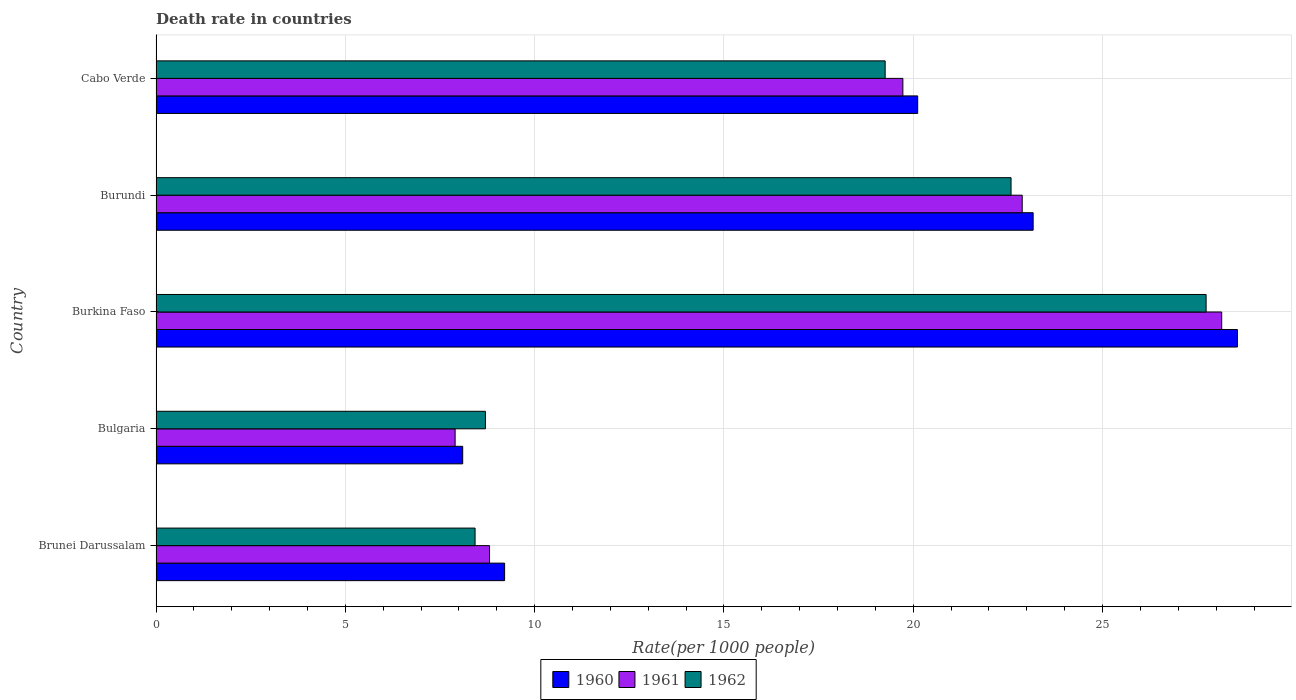Are the number of bars per tick equal to the number of legend labels?
Your answer should be compact. Yes. Are the number of bars on each tick of the Y-axis equal?
Your answer should be compact. Yes. What is the label of the 3rd group of bars from the top?
Keep it short and to the point. Burkina Faso. What is the death rate in 1962 in Burundi?
Offer a very short reply. 22.58. Across all countries, what is the maximum death rate in 1962?
Your response must be concise. 27.73. Across all countries, what is the minimum death rate in 1960?
Your answer should be compact. 8.1. In which country was the death rate in 1961 maximum?
Make the answer very short. Burkina Faso. In which country was the death rate in 1961 minimum?
Offer a terse response. Bulgaria. What is the total death rate in 1960 in the graph?
Give a very brief answer. 89.15. What is the difference between the death rate in 1961 in Bulgaria and that in Burundi?
Ensure brevity in your answer.  -14.98. What is the difference between the death rate in 1962 in Burundi and the death rate in 1961 in Brunei Darussalam?
Your answer should be very brief. 13.77. What is the average death rate in 1962 per country?
Ensure brevity in your answer.  17.34. What is the difference between the death rate in 1960 and death rate in 1961 in Burundi?
Ensure brevity in your answer.  0.29. What is the ratio of the death rate in 1960 in Brunei Darussalam to that in Burkina Faso?
Offer a terse response. 0.32. Is the death rate in 1962 in Brunei Darussalam less than that in Burundi?
Make the answer very short. Yes. What is the difference between the highest and the second highest death rate in 1960?
Your answer should be compact. 5.39. What is the difference between the highest and the lowest death rate in 1961?
Make the answer very short. 20.25. Is it the case that in every country, the sum of the death rate in 1960 and death rate in 1961 is greater than the death rate in 1962?
Your answer should be compact. Yes. How many bars are there?
Offer a very short reply. 15. Are all the bars in the graph horizontal?
Your response must be concise. Yes. What is the difference between two consecutive major ticks on the X-axis?
Give a very brief answer. 5. Does the graph contain any zero values?
Ensure brevity in your answer.  No. How many legend labels are there?
Give a very brief answer. 3. What is the title of the graph?
Offer a very short reply. Death rate in countries. What is the label or title of the X-axis?
Provide a short and direct response. Rate(per 1000 people). What is the label or title of the Y-axis?
Provide a short and direct response. Country. What is the Rate(per 1000 people) in 1960 in Brunei Darussalam?
Your answer should be compact. 9.21. What is the Rate(per 1000 people) in 1961 in Brunei Darussalam?
Ensure brevity in your answer.  8.81. What is the Rate(per 1000 people) in 1962 in Brunei Darussalam?
Provide a succinct answer. 8.43. What is the Rate(per 1000 people) of 1961 in Bulgaria?
Provide a succinct answer. 7.9. What is the Rate(per 1000 people) in 1962 in Bulgaria?
Ensure brevity in your answer.  8.7. What is the Rate(per 1000 people) of 1960 in Burkina Faso?
Offer a very short reply. 28.56. What is the Rate(per 1000 people) of 1961 in Burkina Faso?
Offer a terse response. 28.15. What is the Rate(per 1000 people) of 1962 in Burkina Faso?
Provide a succinct answer. 27.73. What is the Rate(per 1000 people) of 1960 in Burundi?
Offer a very short reply. 23.17. What is the Rate(per 1000 people) in 1961 in Burundi?
Make the answer very short. 22.88. What is the Rate(per 1000 people) of 1962 in Burundi?
Give a very brief answer. 22.58. What is the Rate(per 1000 people) in 1960 in Cabo Verde?
Provide a succinct answer. 20.12. What is the Rate(per 1000 people) of 1961 in Cabo Verde?
Provide a short and direct response. 19.73. What is the Rate(per 1000 people) in 1962 in Cabo Verde?
Your answer should be very brief. 19.26. Across all countries, what is the maximum Rate(per 1000 people) of 1960?
Ensure brevity in your answer.  28.56. Across all countries, what is the maximum Rate(per 1000 people) of 1961?
Ensure brevity in your answer.  28.15. Across all countries, what is the maximum Rate(per 1000 people) in 1962?
Keep it short and to the point. 27.73. Across all countries, what is the minimum Rate(per 1000 people) in 1960?
Offer a very short reply. 8.1. Across all countries, what is the minimum Rate(per 1000 people) of 1962?
Give a very brief answer. 8.43. What is the total Rate(per 1000 people) of 1960 in the graph?
Provide a short and direct response. 89.15. What is the total Rate(per 1000 people) of 1961 in the graph?
Your response must be concise. 87.46. What is the total Rate(per 1000 people) in 1962 in the graph?
Ensure brevity in your answer.  86.7. What is the difference between the Rate(per 1000 people) in 1960 in Brunei Darussalam and that in Bulgaria?
Your answer should be very brief. 1.11. What is the difference between the Rate(per 1000 people) in 1961 in Brunei Darussalam and that in Bulgaria?
Give a very brief answer. 0.91. What is the difference between the Rate(per 1000 people) of 1962 in Brunei Darussalam and that in Bulgaria?
Your answer should be compact. -0.27. What is the difference between the Rate(per 1000 people) of 1960 in Brunei Darussalam and that in Burkina Faso?
Ensure brevity in your answer.  -19.36. What is the difference between the Rate(per 1000 people) in 1961 in Brunei Darussalam and that in Burkina Faso?
Make the answer very short. -19.34. What is the difference between the Rate(per 1000 people) in 1962 in Brunei Darussalam and that in Burkina Faso?
Offer a very short reply. -19.31. What is the difference between the Rate(per 1000 people) of 1960 in Brunei Darussalam and that in Burundi?
Offer a very short reply. -13.96. What is the difference between the Rate(per 1000 people) of 1961 in Brunei Darussalam and that in Burundi?
Offer a very short reply. -14.07. What is the difference between the Rate(per 1000 people) in 1962 in Brunei Darussalam and that in Burundi?
Keep it short and to the point. -14.16. What is the difference between the Rate(per 1000 people) of 1960 in Brunei Darussalam and that in Cabo Verde?
Offer a very short reply. -10.91. What is the difference between the Rate(per 1000 people) of 1961 in Brunei Darussalam and that in Cabo Verde?
Your answer should be very brief. -10.92. What is the difference between the Rate(per 1000 people) in 1962 in Brunei Darussalam and that in Cabo Verde?
Make the answer very short. -10.83. What is the difference between the Rate(per 1000 people) in 1960 in Bulgaria and that in Burkina Faso?
Provide a short and direct response. -20.46. What is the difference between the Rate(per 1000 people) of 1961 in Bulgaria and that in Burkina Faso?
Your answer should be very brief. -20.25. What is the difference between the Rate(per 1000 people) in 1962 in Bulgaria and that in Burkina Faso?
Your answer should be compact. -19.04. What is the difference between the Rate(per 1000 people) of 1960 in Bulgaria and that in Burundi?
Provide a short and direct response. -15.07. What is the difference between the Rate(per 1000 people) in 1961 in Bulgaria and that in Burundi?
Offer a terse response. -14.98. What is the difference between the Rate(per 1000 people) in 1962 in Bulgaria and that in Burundi?
Ensure brevity in your answer.  -13.88. What is the difference between the Rate(per 1000 people) of 1960 in Bulgaria and that in Cabo Verde?
Offer a terse response. -12.02. What is the difference between the Rate(per 1000 people) in 1961 in Bulgaria and that in Cabo Verde?
Offer a terse response. -11.83. What is the difference between the Rate(per 1000 people) of 1962 in Bulgaria and that in Cabo Verde?
Make the answer very short. -10.56. What is the difference between the Rate(per 1000 people) in 1960 in Burkina Faso and that in Burundi?
Your response must be concise. 5.39. What is the difference between the Rate(per 1000 people) of 1961 in Burkina Faso and that in Burundi?
Offer a terse response. 5.27. What is the difference between the Rate(per 1000 people) in 1962 in Burkina Faso and that in Burundi?
Ensure brevity in your answer.  5.15. What is the difference between the Rate(per 1000 people) of 1960 in Burkina Faso and that in Cabo Verde?
Your response must be concise. 8.45. What is the difference between the Rate(per 1000 people) in 1961 in Burkina Faso and that in Cabo Verde?
Offer a very short reply. 8.42. What is the difference between the Rate(per 1000 people) of 1962 in Burkina Faso and that in Cabo Verde?
Provide a succinct answer. 8.48. What is the difference between the Rate(per 1000 people) of 1960 in Burundi and that in Cabo Verde?
Offer a terse response. 3.05. What is the difference between the Rate(per 1000 people) of 1961 in Burundi and that in Cabo Verde?
Your answer should be very brief. 3.15. What is the difference between the Rate(per 1000 people) of 1962 in Burundi and that in Cabo Verde?
Your answer should be compact. 3.33. What is the difference between the Rate(per 1000 people) of 1960 in Brunei Darussalam and the Rate(per 1000 people) of 1961 in Bulgaria?
Provide a short and direct response. 1.31. What is the difference between the Rate(per 1000 people) in 1960 in Brunei Darussalam and the Rate(per 1000 people) in 1962 in Bulgaria?
Your answer should be very brief. 0.51. What is the difference between the Rate(per 1000 people) of 1961 in Brunei Darussalam and the Rate(per 1000 people) of 1962 in Bulgaria?
Your answer should be very brief. 0.11. What is the difference between the Rate(per 1000 people) in 1960 in Brunei Darussalam and the Rate(per 1000 people) in 1961 in Burkina Faso?
Your response must be concise. -18.94. What is the difference between the Rate(per 1000 people) of 1960 in Brunei Darussalam and the Rate(per 1000 people) of 1962 in Burkina Faso?
Your response must be concise. -18.53. What is the difference between the Rate(per 1000 people) of 1961 in Brunei Darussalam and the Rate(per 1000 people) of 1962 in Burkina Faso?
Provide a short and direct response. -18.93. What is the difference between the Rate(per 1000 people) in 1960 in Brunei Darussalam and the Rate(per 1000 people) in 1961 in Burundi?
Your response must be concise. -13.67. What is the difference between the Rate(per 1000 people) in 1960 in Brunei Darussalam and the Rate(per 1000 people) in 1962 in Burundi?
Offer a very short reply. -13.38. What is the difference between the Rate(per 1000 people) of 1961 in Brunei Darussalam and the Rate(per 1000 people) of 1962 in Burundi?
Your answer should be compact. -13.77. What is the difference between the Rate(per 1000 people) in 1960 in Brunei Darussalam and the Rate(per 1000 people) in 1961 in Cabo Verde?
Offer a terse response. -10.52. What is the difference between the Rate(per 1000 people) of 1960 in Brunei Darussalam and the Rate(per 1000 people) of 1962 in Cabo Verde?
Give a very brief answer. -10.05. What is the difference between the Rate(per 1000 people) in 1961 in Brunei Darussalam and the Rate(per 1000 people) in 1962 in Cabo Verde?
Make the answer very short. -10.45. What is the difference between the Rate(per 1000 people) of 1960 in Bulgaria and the Rate(per 1000 people) of 1961 in Burkina Faso?
Provide a succinct answer. -20.05. What is the difference between the Rate(per 1000 people) in 1960 in Bulgaria and the Rate(per 1000 people) in 1962 in Burkina Faso?
Your answer should be compact. -19.64. What is the difference between the Rate(per 1000 people) of 1961 in Bulgaria and the Rate(per 1000 people) of 1962 in Burkina Faso?
Offer a very short reply. -19.84. What is the difference between the Rate(per 1000 people) in 1960 in Bulgaria and the Rate(per 1000 people) in 1961 in Burundi?
Provide a short and direct response. -14.78. What is the difference between the Rate(per 1000 people) of 1960 in Bulgaria and the Rate(per 1000 people) of 1962 in Burundi?
Provide a short and direct response. -14.48. What is the difference between the Rate(per 1000 people) in 1961 in Bulgaria and the Rate(per 1000 people) in 1962 in Burundi?
Your answer should be very brief. -14.68. What is the difference between the Rate(per 1000 people) of 1960 in Bulgaria and the Rate(per 1000 people) of 1961 in Cabo Verde?
Provide a short and direct response. -11.63. What is the difference between the Rate(per 1000 people) in 1960 in Bulgaria and the Rate(per 1000 people) in 1962 in Cabo Verde?
Keep it short and to the point. -11.16. What is the difference between the Rate(per 1000 people) of 1961 in Bulgaria and the Rate(per 1000 people) of 1962 in Cabo Verde?
Provide a succinct answer. -11.36. What is the difference between the Rate(per 1000 people) of 1960 in Burkina Faso and the Rate(per 1000 people) of 1961 in Burundi?
Provide a succinct answer. 5.68. What is the difference between the Rate(per 1000 people) of 1960 in Burkina Faso and the Rate(per 1000 people) of 1962 in Burundi?
Your answer should be compact. 5.98. What is the difference between the Rate(per 1000 people) of 1961 in Burkina Faso and the Rate(per 1000 people) of 1962 in Burundi?
Your answer should be compact. 5.56. What is the difference between the Rate(per 1000 people) in 1960 in Burkina Faso and the Rate(per 1000 people) in 1961 in Cabo Verde?
Ensure brevity in your answer.  8.84. What is the difference between the Rate(per 1000 people) in 1960 in Burkina Faso and the Rate(per 1000 people) in 1962 in Cabo Verde?
Provide a succinct answer. 9.3. What is the difference between the Rate(per 1000 people) of 1961 in Burkina Faso and the Rate(per 1000 people) of 1962 in Cabo Verde?
Keep it short and to the point. 8.89. What is the difference between the Rate(per 1000 people) of 1960 in Burundi and the Rate(per 1000 people) of 1961 in Cabo Verde?
Your answer should be very brief. 3.44. What is the difference between the Rate(per 1000 people) in 1960 in Burundi and the Rate(per 1000 people) in 1962 in Cabo Verde?
Offer a very short reply. 3.91. What is the difference between the Rate(per 1000 people) of 1961 in Burundi and the Rate(per 1000 people) of 1962 in Cabo Verde?
Make the answer very short. 3.62. What is the average Rate(per 1000 people) in 1960 per country?
Provide a succinct answer. 17.83. What is the average Rate(per 1000 people) in 1961 per country?
Provide a short and direct response. 17.49. What is the average Rate(per 1000 people) in 1962 per country?
Make the answer very short. 17.34. What is the difference between the Rate(per 1000 people) in 1960 and Rate(per 1000 people) in 1961 in Brunei Darussalam?
Provide a short and direct response. 0.4. What is the difference between the Rate(per 1000 people) in 1960 and Rate(per 1000 people) in 1962 in Brunei Darussalam?
Your answer should be compact. 0.78. What is the difference between the Rate(per 1000 people) of 1961 and Rate(per 1000 people) of 1962 in Brunei Darussalam?
Offer a very short reply. 0.38. What is the difference between the Rate(per 1000 people) in 1960 and Rate(per 1000 people) in 1961 in Bulgaria?
Give a very brief answer. 0.2. What is the difference between the Rate(per 1000 people) of 1960 and Rate(per 1000 people) of 1962 in Bulgaria?
Your answer should be compact. -0.6. What is the difference between the Rate(per 1000 people) in 1961 and Rate(per 1000 people) in 1962 in Bulgaria?
Your answer should be compact. -0.8. What is the difference between the Rate(per 1000 people) in 1960 and Rate(per 1000 people) in 1961 in Burkina Faso?
Your answer should be compact. 0.41. What is the difference between the Rate(per 1000 people) in 1960 and Rate(per 1000 people) in 1962 in Burkina Faso?
Provide a succinct answer. 0.83. What is the difference between the Rate(per 1000 people) in 1961 and Rate(per 1000 people) in 1962 in Burkina Faso?
Offer a terse response. 0.41. What is the difference between the Rate(per 1000 people) of 1960 and Rate(per 1000 people) of 1961 in Burundi?
Provide a short and direct response. 0.29. What is the difference between the Rate(per 1000 people) of 1960 and Rate(per 1000 people) of 1962 in Burundi?
Ensure brevity in your answer.  0.58. What is the difference between the Rate(per 1000 people) in 1961 and Rate(per 1000 people) in 1962 in Burundi?
Offer a terse response. 0.29. What is the difference between the Rate(per 1000 people) in 1960 and Rate(per 1000 people) in 1961 in Cabo Verde?
Provide a succinct answer. 0.39. What is the difference between the Rate(per 1000 people) of 1960 and Rate(per 1000 people) of 1962 in Cabo Verde?
Your response must be concise. 0.86. What is the difference between the Rate(per 1000 people) in 1961 and Rate(per 1000 people) in 1962 in Cabo Verde?
Offer a terse response. 0.47. What is the ratio of the Rate(per 1000 people) of 1960 in Brunei Darussalam to that in Bulgaria?
Your response must be concise. 1.14. What is the ratio of the Rate(per 1000 people) in 1961 in Brunei Darussalam to that in Bulgaria?
Make the answer very short. 1.12. What is the ratio of the Rate(per 1000 people) in 1962 in Brunei Darussalam to that in Bulgaria?
Your answer should be very brief. 0.97. What is the ratio of the Rate(per 1000 people) in 1960 in Brunei Darussalam to that in Burkina Faso?
Make the answer very short. 0.32. What is the ratio of the Rate(per 1000 people) in 1961 in Brunei Darussalam to that in Burkina Faso?
Offer a terse response. 0.31. What is the ratio of the Rate(per 1000 people) in 1962 in Brunei Darussalam to that in Burkina Faso?
Give a very brief answer. 0.3. What is the ratio of the Rate(per 1000 people) of 1960 in Brunei Darussalam to that in Burundi?
Provide a succinct answer. 0.4. What is the ratio of the Rate(per 1000 people) of 1961 in Brunei Darussalam to that in Burundi?
Make the answer very short. 0.39. What is the ratio of the Rate(per 1000 people) in 1962 in Brunei Darussalam to that in Burundi?
Your answer should be very brief. 0.37. What is the ratio of the Rate(per 1000 people) in 1960 in Brunei Darussalam to that in Cabo Verde?
Offer a very short reply. 0.46. What is the ratio of the Rate(per 1000 people) in 1961 in Brunei Darussalam to that in Cabo Verde?
Your answer should be very brief. 0.45. What is the ratio of the Rate(per 1000 people) of 1962 in Brunei Darussalam to that in Cabo Verde?
Offer a terse response. 0.44. What is the ratio of the Rate(per 1000 people) of 1960 in Bulgaria to that in Burkina Faso?
Offer a terse response. 0.28. What is the ratio of the Rate(per 1000 people) of 1961 in Bulgaria to that in Burkina Faso?
Offer a terse response. 0.28. What is the ratio of the Rate(per 1000 people) in 1962 in Bulgaria to that in Burkina Faso?
Offer a very short reply. 0.31. What is the ratio of the Rate(per 1000 people) in 1960 in Bulgaria to that in Burundi?
Offer a terse response. 0.35. What is the ratio of the Rate(per 1000 people) in 1961 in Bulgaria to that in Burundi?
Keep it short and to the point. 0.35. What is the ratio of the Rate(per 1000 people) of 1962 in Bulgaria to that in Burundi?
Your response must be concise. 0.39. What is the ratio of the Rate(per 1000 people) of 1960 in Bulgaria to that in Cabo Verde?
Offer a very short reply. 0.4. What is the ratio of the Rate(per 1000 people) of 1961 in Bulgaria to that in Cabo Verde?
Give a very brief answer. 0.4. What is the ratio of the Rate(per 1000 people) of 1962 in Bulgaria to that in Cabo Verde?
Your answer should be compact. 0.45. What is the ratio of the Rate(per 1000 people) in 1960 in Burkina Faso to that in Burundi?
Your answer should be compact. 1.23. What is the ratio of the Rate(per 1000 people) of 1961 in Burkina Faso to that in Burundi?
Your answer should be compact. 1.23. What is the ratio of the Rate(per 1000 people) in 1962 in Burkina Faso to that in Burundi?
Offer a very short reply. 1.23. What is the ratio of the Rate(per 1000 people) in 1960 in Burkina Faso to that in Cabo Verde?
Ensure brevity in your answer.  1.42. What is the ratio of the Rate(per 1000 people) of 1961 in Burkina Faso to that in Cabo Verde?
Keep it short and to the point. 1.43. What is the ratio of the Rate(per 1000 people) of 1962 in Burkina Faso to that in Cabo Verde?
Offer a very short reply. 1.44. What is the ratio of the Rate(per 1000 people) in 1960 in Burundi to that in Cabo Verde?
Your response must be concise. 1.15. What is the ratio of the Rate(per 1000 people) of 1961 in Burundi to that in Cabo Verde?
Offer a very short reply. 1.16. What is the ratio of the Rate(per 1000 people) of 1962 in Burundi to that in Cabo Verde?
Offer a terse response. 1.17. What is the difference between the highest and the second highest Rate(per 1000 people) in 1960?
Provide a short and direct response. 5.39. What is the difference between the highest and the second highest Rate(per 1000 people) of 1961?
Ensure brevity in your answer.  5.27. What is the difference between the highest and the second highest Rate(per 1000 people) of 1962?
Ensure brevity in your answer.  5.15. What is the difference between the highest and the lowest Rate(per 1000 people) of 1960?
Keep it short and to the point. 20.46. What is the difference between the highest and the lowest Rate(per 1000 people) of 1961?
Ensure brevity in your answer.  20.25. What is the difference between the highest and the lowest Rate(per 1000 people) of 1962?
Provide a short and direct response. 19.31. 